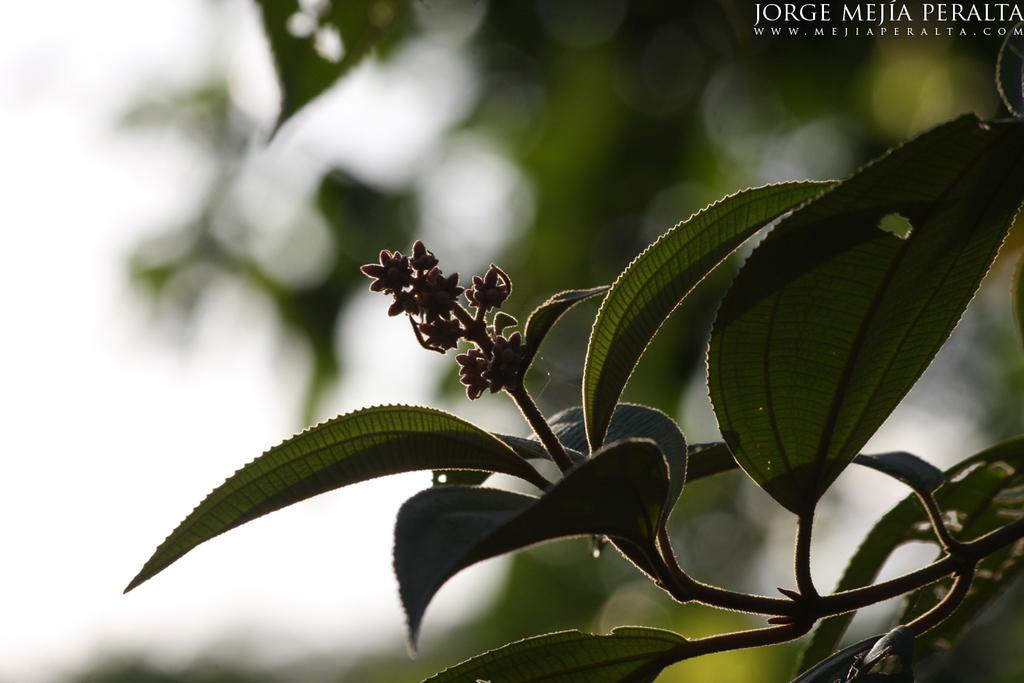What is the main subject in the center of the image? There is a tree in the center of the image. Is there any text or marking in the image? Yes, there is a watermark in the top right corner of the image. What type of cake is being served in the room depicted in the image? There is no cake or room present in the image; it only features a tree and a watermark. 